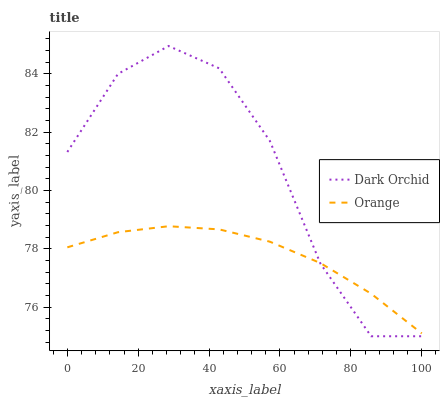Does Orange have the minimum area under the curve?
Answer yes or no. Yes. Does Dark Orchid have the maximum area under the curve?
Answer yes or no. Yes. Does Dark Orchid have the minimum area under the curve?
Answer yes or no. No. Is Orange the smoothest?
Answer yes or no. Yes. Is Dark Orchid the roughest?
Answer yes or no. Yes. Is Dark Orchid the smoothest?
Answer yes or no. No. Does Dark Orchid have the lowest value?
Answer yes or no. Yes. Does Dark Orchid have the highest value?
Answer yes or no. Yes. Does Orange intersect Dark Orchid?
Answer yes or no. Yes. Is Orange less than Dark Orchid?
Answer yes or no. No. Is Orange greater than Dark Orchid?
Answer yes or no. No. 